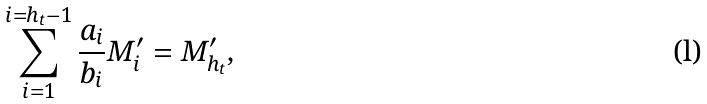<formula> <loc_0><loc_0><loc_500><loc_500>\sum _ { i = 1 } ^ { i = h _ { t } - 1 } \frac { a _ { i } } { b _ { i } } M ^ { \prime } _ { i } = M ^ { \prime } _ { h _ { t } } ,</formula> 